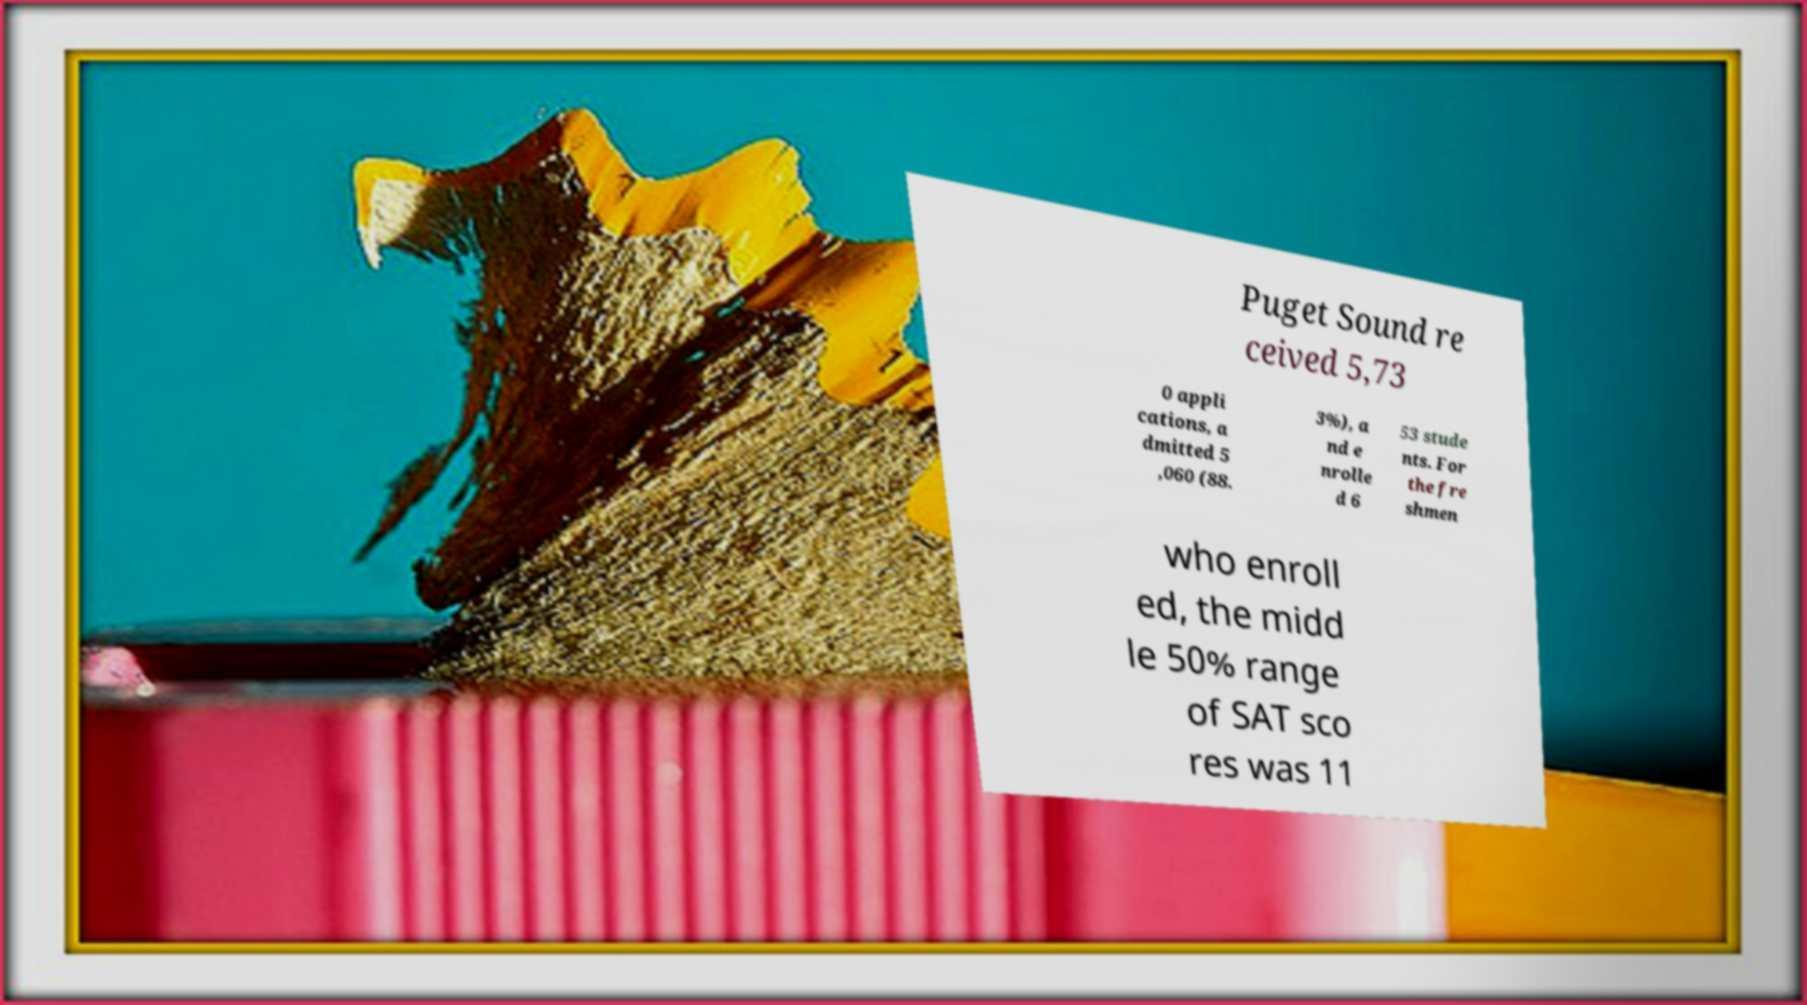Can you accurately transcribe the text from the provided image for me? Puget Sound re ceived 5,73 0 appli cations, a dmitted 5 ,060 (88. 3%), a nd e nrolle d 6 53 stude nts. For the fre shmen who enroll ed, the midd le 50% range of SAT sco res was 11 